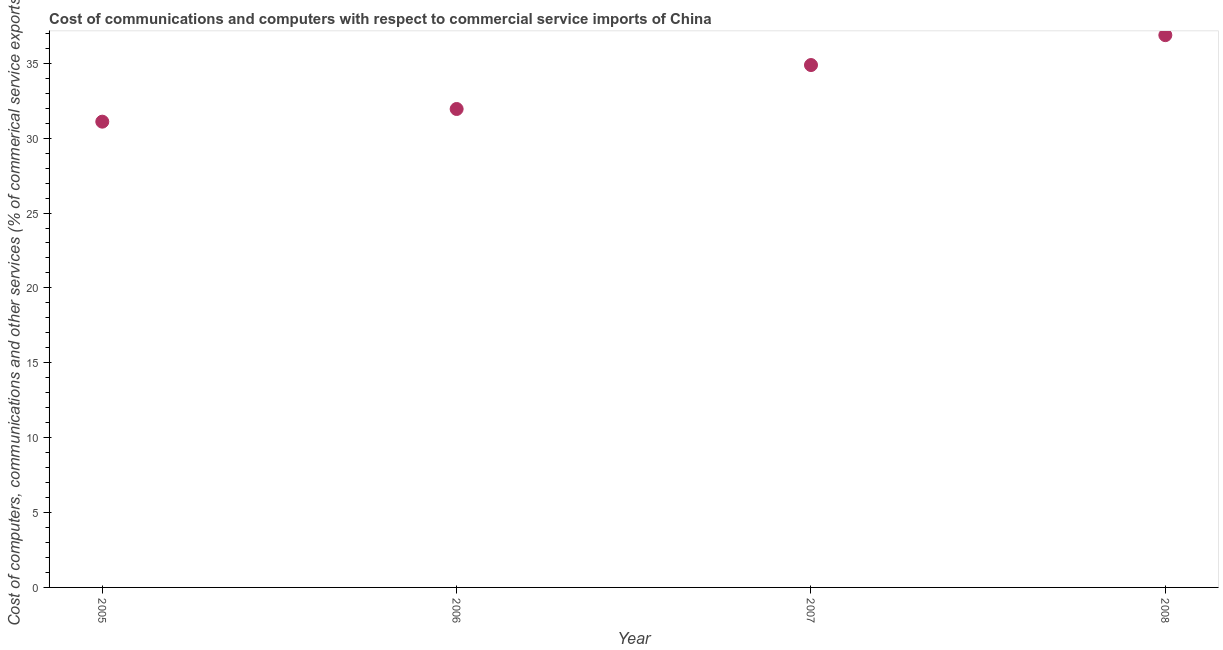What is the cost of communications in 2005?
Your answer should be compact. 31.1. Across all years, what is the maximum cost of communications?
Your answer should be very brief. 36.88. Across all years, what is the minimum cost of communications?
Provide a short and direct response. 31.1. What is the sum of the cost of communications?
Offer a very short reply. 134.81. What is the difference between the cost of communications in 2005 and 2008?
Provide a succinct answer. -5.78. What is the average cost of communications per year?
Your answer should be very brief. 33.7. What is the median  computer and other services?
Provide a short and direct response. 33.41. In how many years, is the cost of communications greater than 9 %?
Keep it short and to the point. 4. Do a majority of the years between 2007 and 2006 (inclusive) have  computer and other services greater than 35 %?
Offer a terse response. No. What is the ratio of the  computer and other services in 2005 to that in 2007?
Provide a succinct answer. 0.89. Is the difference between the  computer and other services in 2006 and 2008 greater than the difference between any two years?
Your answer should be very brief. No. What is the difference between the highest and the second highest cost of communications?
Give a very brief answer. 2. What is the difference between the highest and the lowest  computer and other services?
Give a very brief answer. 5.78. What is the difference between two consecutive major ticks on the Y-axis?
Make the answer very short. 5. Are the values on the major ticks of Y-axis written in scientific E-notation?
Make the answer very short. No. Does the graph contain any zero values?
Keep it short and to the point. No. Does the graph contain grids?
Offer a terse response. No. What is the title of the graph?
Provide a succinct answer. Cost of communications and computers with respect to commercial service imports of China. What is the label or title of the X-axis?
Your answer should be compact. Year. What is the label or title of the Y-axis?
Make the answer very short. Cost of computers, communications and other services (% of commerical service exports). What is the Cost of computers, communications and other services (% of commerical service exports) in 2005?
Make the answer very short. 31.1. What is the Cost of computers, communications and other services (% of commerical service exports) in 2006?
Give a very brief answer. 31.95. What is the Cost of computers, communications and other services (% of commerical service exports) in 2007?
Provide a succinct answer. 34.88. What is the Cost of computers, communications and other services (% of commerical service exports) in 2008?
Ensure brevity in your answer.  36.88. What is the difference between the Cost of computers, communications and other services (% of commerical service exports) in 2005 and 2006?
Provide a short and direct response. -0.85. What is the difference between the Cost of computers, communications and other services (% of commerical service exports) in 2005 and 2007?
Keep it short and to the point. -3.78. What is the difference between the Cost of computers, communications and other services (% of commerical service exports) in 2005 and 2008?
Give a very brief answer. -5.78. What is the difference between the Cost of computers, communications and other services (% of commerical service exports) in 2006 and 2007?
Provide a short and direct response. -2.93. What is the difference between the Cost of computers, communications and other services (% of commerical service exports) in 2006 and 2008?
Ensure brevity in your answer.  -4.93. What is the difference between the Cost of computers, communications and other services (% of commerical service exports) in 2007 and 2008?
Keep it short and to the point. -2. What is the ratio of the Cost of computers, communications and other services (% of commerical service exports) in 2005 to that in 2006?
Give a very brief answer. 0.97. What is the ratio of the Cost of computers, communications and other services (% of commerical service exports) in 2005 to that in 2007?
Keep it short and to the point. 0.89. What is the ratio of the Cost of computers, communications and other services (% of commerical service exports) in 2005 to that in 2008?
Make the answer very short. 0.84. What is the ratio of the Cost of computers, communications and other services (% of commerical service exports) in 2006 to that in 2007?
Provide a succinct answer. 0.92. What is the ratio of the Cost of computers, communications and other services (% of commerical service exports) in 2006 to that in 2008?
Offer a very short reply. 0.87. What is the ratio of the Cost of computers, communications and other services (% of commerical service exports) in 2007 to that in 2008?
Your answer should be compact. 0.95. 